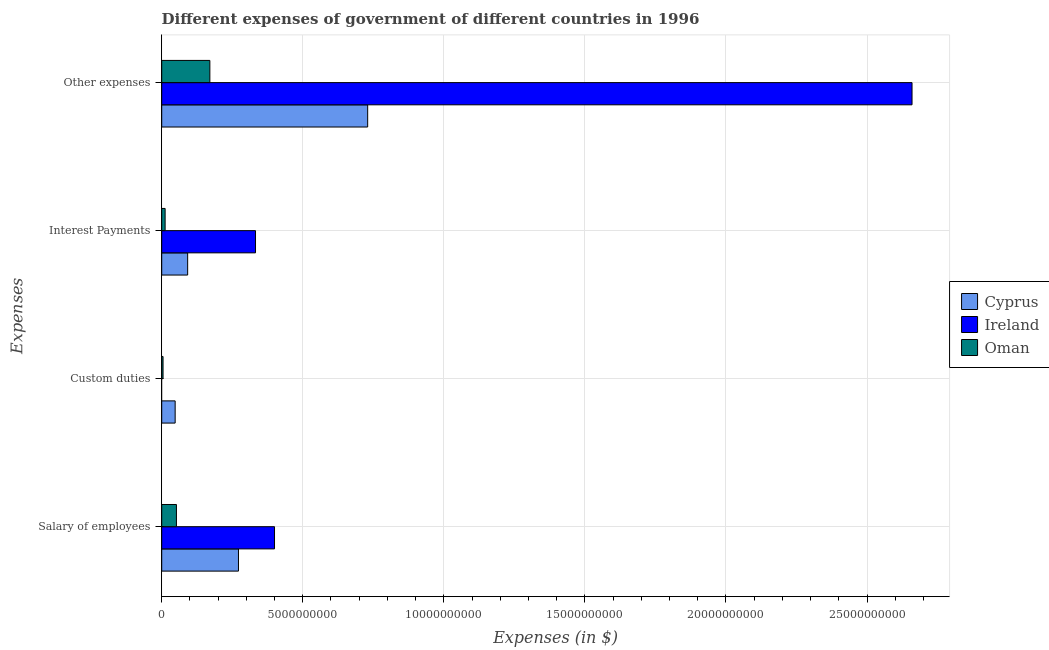Are the number of bars per tick equal to the number of legend labels?
Make the answer very short. No. Are the number of bars on each tick of the Y-axis equal?
Make the answer very short. No. How many bars are there on the 3rd tick from the top?
Your response must be concise. 2. What is the label of the 4th group of bars from the top?
Your response must be concise. Salary of employees. What is the amount spent on other expenses in Ireland?
Ensure brevity in your answer.  2.66e+1. Across all countries, what is the maximum amount spent on other expenses?
Ensure brevity in your answer.  2.66e+1. Across all countries, what is the minimum amount spent on interest payments?
Offer a terse response. 1.21e+08. In which country was the amount spent on other expenses maximum?
Keep it short and to the point. Ireland. What is the total amount spent on salary of employees in the graph?
Provide a succinct answer. 7.24e+09. What is the difference between the amount spent on other expenses in Cyprus and that in Ireland?
Your answer should be compact. -1.93e+1. What is the difference between the amount spent on interest payments in Ireland and the amount spent on salary of employees in Oman?
Provide a succinct answer. 2.80e+09. What is the average amount spent on interest payments per country?
Your answer should be very brief. 1.46e+09. What is the difference between the amount spent on salary of employees and amount spent on other expenses in Ireland?
Ensure brevity in your answer.  -2.26e+1. In how many countries, is the amount spent on salary of employees greater than 14000000000 $?
Provide a succinct answer. 0. What is the ratio of the amount spent on salary of employees in Cyprus to that in Oman?
Provide a short and direct response. 5.21. Is the difference between the amount spent on salary of employees in Oman and Ireland greater than the difference between the amount spent on interest payments in Oman and Ireland?
Make the answer very short. No. What is the difference between the highest and the second highest amount spent on salary of employees?
Make the answer very short. 1.28e+09. What is the difference between the highest and the lowest amount spent on custom duties?
Ensure brevity in your answer.  4.77e+08. Is the sum of the amount spent on other expenses in Oman and Ireland greater than the maximum amount spent on interest payments across all countries?
Give a very brief answer. Yes. Are all the bars in the graph horizontal?
Give a very brief answer. Yes. Does the graph contain any zero values?
Keep it short and to the point. Yes. Does the graph contain grids?
Offer a terse response. Yes. Where does the legend appear in the graph?
Provide a short and direct response. Center right. How many legend labels are there?
Offer a terse response. 3. How are the legend labels stacked?
Provide a short and direct response. Vertical. What is the title of the graph?
Provide a succinct answer. Different expenses of government of different countries in 1996. Does "Georgia" appear as one of the legend labels in the graph?
Your response must be concise. No. What is the label or title of the X-axis?
Make the answer very short. Expenses (in $). What is the label or title of the Y-axis?
Provide a succinct answer. Expenses. What is the Expenses (in $) in Cyprus in Salary of employees?
Your answer should be very brief. 2.72e+09. What is the Expenses (in $) in Ireland in Salary of employees?
Make the answer very short. 4.00e+09. What is the Expenses (in $) in Oman in Salary of employees?
Make the answer very short. 5.22e+08. What is the Expenses (in $) of Cyprus in Custom duties?
Ensure brevity in your answer.  4.77e+08. What is the Expenses (in $) of Ireland in Custom duties?
Your answer should be compact. 0. What is the Expenses (in $) in Oman in Custom duties?
Offer a terse response. 4.76e+07. What is the Expenses (in $) of Cyprus in Interest Payments?
Give a very brief answer. 9.20e+08. What is the Expenses (in $) in Ireland in Interest Payments?
Offer a very short reply. 3.32e+09. What is the Expenses (in $) in Oman in Interest Payments?
Give a very brief answer. 1.21e+08. What is the Expenses (in $) of Cyprus in Other expenses?
Your answer should be compact. 7.30e+09. What is the Expenses (in $) in Ireland in Other expenses?
Offer a terse response. 2.66e+1. What is the Expenses (in $) of Oman in Other expenses?
Ensure brevity in your answer.  1.71e+09. Across all Expenses, what is the maximum Expenses (in $) of Cyprus?
Offer a very short reply. 7.30e+09. Across all Expenses, what is the maximum Expenses (in $) in Ireland?
Give a very brief answer. 2.66e+1. Across all Expenses, what is the maximum Expenses (in $) in Oman?
Ensure brevity in your answer.  1.71e+09. Across all Expenses, what is the minimum Expenses (in $) in Cyprus?
Your answer should be compact. 4.77e+08. Across all Expenses, what is the minimum Expenses (in $) of Ireland?
Provide a short and direct response. 0. Across all Expenses, what is the minimum Expenses (in $) in Oman?
Ensure brevity in your answer.  4.76e+07. What is the total Expenses (in $) of Cyprus in the graph?
Make the answer very short. 1.14e+1. What is the total Expenses (in $) in Ireland in the graph?
Your answer should be compact. 3.39e+1. What is the total Expenses (in $) in Oman in the graph?
Provide a short and direct response. 2.40e+09. What is the difference between the Expenses (in $) in Cyprus in Salary of employees and that in Custom duties?
Ensure brevity in your answer.  2.24e+09. What is the difference between the Expenses (in $) in Oman in Salary of employees and that in Custom duties?
Give a very brief answer. 4.74e+08. What is the difference between the Expenses (in $) in Cyprus in Salary of employees and that in Interest Payments?
Provide a short and direct response. 1.80e+09. What is the difference between the Expenses (in $) of Ireland in Salary of employees and that in Interest Payments?
Offer a very short reply. 6.74e+08. What is the difference between the Expenses (in $) of Oman in Salary of employees and that in Interest Payments?
Provide a short and direct response. 4.01e+08. What is the difference between the Expenses (in $) of Cyprus in Salary of employees and that in Other expenses?
Your response must be concise. -4.58e+09. What is the difference between the Expenses (in $) of Ireland in Salary of employees and that in Other expenses?
Your answer should be very brief. -2.26e+1. What is the difference between the Expenses (in $) of Oman in Salary of employees and that in Other expenses?
Provide a short and direct response. -1.18e+09. What is the difference between the Expenses (in $) in Cyprus in Custom duties and that in Interest Payments?
Keep it short and to the point. -4.43e+08. What is the difference between the Expenses (in $) of Oman in Custom duties and that in Interest Payments?
Offer a terse response. -7.36e+07. What is the difference between the Expenses (in $) in Cyprus in Custom duties and that in Other expenses?
Your answer should be very brief. -6.82e+09. What is the difference between the Expenses (in $) in Oman in Custom duties and that in Other expenses?
Give a very brief answer. -1.66e+09. What is the difference between the Expenses (in $) of Cyprus in Interest Payments and that in Other expenses?
Keep it short and to the point. -6.38e+09. What is the difference between the Expenses (in $) of Ireland in Interest Payments and that in Other expenses?
Offer a very short reply. -2.33e+1. What is the difference between the Expenses (in $) of Oman in Interest Payments and that in Other expenses?
Provide a succinct answer. -1.59e+09. What is the difference between the Expenses (in $) of Cyprus in Salary of employees and the Expenses (in $) of Oman in Custom duties?
Provide a succinct answer. 2.67e+09. What is the difference between the Expenses (in $) of Ireland in Salary of employees and the Expenses (in $) of Oman in Custom duties?
Give a very brief answer. 3.95e+09. What is the difference between the Expenses (in $) of Cyprus in Salary of employees and the Expenses (in $) of Ireland in Interest Payments?
Offer a very short reply. -6.04e+08. What is the difference between the Expenses (in $) in Cyprus in Salary of employees and the Expenses (in $) in Oman in Interest Payments?
Provide a short and direct response. 2.60e+09. What is the difference between the Expenses (in $) in Ireland in Salary of employees and the Expenses (in $) in Oman in Interest Payments?
Provide a succinct answer. 3.88e+09. What is the difference between the Expenses (in $) of Cyprus in Salary of employees and the Expenses (in $) of Ireland in Other expenses?
Offer a very short reply. -2.39e+1. What is the difference between the Expenses (in $) in Cyprus in Salary of employees and the Expenses (in $) in Oman in Other expenses?
Provide a short and direct response. 1.01e+09. What is the difference between the Expenses (in $) in Ireland in Salary of employees and the Expenses (in $) in Oman in Other expenses?
Keep it short and to the point. 2.29e+09. What is the difference between the Expenses (in $) of Cyprus in Custom duties and the Expenses (in $) of Ireland in Interest Payments?
Provide a succinct answer. -2.85e+09. What is the difference between the Expenses (in $) in Cyprus in Custom duties and the Expenses (in $) in Oman in Interest Payments?
Ensure brevity in your answer.  3.56e+08. What is the difference between the Expenses (in $) in Cyprus in Custom duties and the Expenses (in $) in Ireland in Other expenses?
Make the answer very short. -2.61e+1. What is the difference between the Expenses (in $) in Cyprus in Custom duties and the Expenses (in $) in Oman in Other expenses?
Make the answer very short. -1.23e+09. What is the difference between the Expenses (in $) in Cyprus in Interest Payments and the Expenses (in $) in Ireland in Other expenses?
Provide a short and direct response. -2.57e+1. What is the difference between the Expenses (in $) in Cyprus in Interest Payments and the Expenses (in $) in Oman in Other expenses?
Your answer should be very brief. -7.87e+08. What is the difference between the Expenses (in $) of Ireland in Interest Payments and the Expenses (in $) of Oman in Other expenses?
Your response must be concise. 1.62e+09. What is the average Expenses (in $) of Cyprus per Expenses?
Your response must be concise. 2.85e+09. What is the average Expenses (in $) of Ireland per Expenses?
Provide a succinct answer. 8.48e+09. What is the average Expenses (in $) in Oman per Expenses?
Keep it short and to the point. 5.99e+08. What is the difference between the Expenses (in $) of Cyprus and Expenses (in $) of Ireland in Salary of employees?
Give a very brief answer. -1.28e+09. What is the difference between the Expenses (in $) in Cyprus and Expenses (in $) in Oman in Salary of employees?
Give a very brief answer. 2.20e+09. What is the difference between the Expenses (in $) in Ireland and Expenses (in $) in Oman in Salary of employees?
Ensure brevity in your answer.  3.48e+09. What is the difference between the Expenses (in $) in Cyprus and Expenses (in $) in Oman in Custom duties?
Keep it short and to the point. 4.29e+08. What is the difference between the Expenses (in $) in Cyprus and Expenses (in $) in Ireland in Interest Payments?
Provide a succinct answer. -2.40e+09. What is the difference between the Expenses (in $) of Cyprus and Expenses (in $) of Oman in Interest Payments?
Keep it short and to the point. 7.99e+08. What is the difference between the Expenses (in $) of Ireland and Expenses (in $) of Oman in Interest Payments?
Offer a terse response. 3.20e+09. What is the difference between the Expenses (in $) of Cyprus and Expenses (in $) of Ireland in Other expenses?
Offer a very short reply. -1.93e+1. What is the difference between the Expenses (in $) of Cyprus and Expenses (in $) of Oman in Other expenses?
Make the answer very short. 5.59e+09. What is the difference between the Expenses (in $) in Ireland and Expenses (in $) in Oman in Other expenses?
Make the answer very short. 2.49e+1. What is the ratio of the Expenses (in $) of Cyprus in Salary of employees to that in Custom duties?
Keep it short and to the point. 5.71. What is the ratio of the Expenses (in $) of Oman in Salary of employees to that in Custom duties?
Your answer should be compact. 10.96. What is the ratio of the Expenses (in $) of Cyprus in Salary of employees to that in Interest Payments?
Your response must be concise. 2.96. What is the ratio of the Expenses (in $) of Ireland in Salary of employees to that in Interest Payments?
Keep it short and to the point. 1.2. What is the ratio of the Expenses (in $) in Oman in Salary of employees to that in Interest Payments?
Keep it short and to the point. 4.31. What is the ratio of the Expenses (in $) in Cyprus in Salary of employees to that in Other expenses?
Offer a terse response. 0.37. What is the ratio of the Expenses (in $) of Ireland in Salary of employees to that in Other expenses?
Your answer should be very brief. 0.15. What is the ratio of the Expenses (in $) of Oman in Salary of employees to that in Other expenses?
Ensure brevity in your answer.  0.31. What is the ratio of the Expenses (in $) of Cyprus in Custom duties to that in Interest Payments?
Your response must be concise. 0.52. What is the ratio of the Expenses (in $) in Oman in Custom duties to that in Interest Payments?
Your answer should be compact. 0.39. What is the ratio of the Expenses (in $) in Cyprus in Custom duties to that in Other expenses?
Provide a short and direct response. 0.07. What is the ratio of the Expenses (in $) of Oman in Custom duties to that in Other expenses?
Your answer should be compact. 0.03. What is the ratio of the Expenses (in $) in Cyprus in Interest Payments to that in Other expenses?
Your response must be concise. 0.13. What is the ratio of the Expenses (in $) in Ireland in Interest Payments to that in Other expenses?
Provide a short and direct response. 0.12. What is the ratio of the Expenses (in $) in Oman in Interest Payments to that in Other expenses?
Your answer should be compact. 0.07. What is the difference between the highest and the second highest Expenses (in $) of Cyprus?
Keep it short and to the point. 4.58e+09. What is the difference between the highest and the second highest Expenses (in $) of Ireland?
Your answer should be very brief. 2.26e+1. What is the difference between the highest and the second highest Expenses (in $) in Oman?
Keep it short and to the point. 1.18e+09. What is the difference between the highest and the lowest Expenses (in $) in Cyprus?
Your response must be concise. 6.82e+09. What is the difference between the highest and the lowest Expenses (in $) in Ireland?
Your answer should be very brief. 2.66e+1. What is the difference between the highest and the lowest Expenses (in $) in Oman?
Provide a succinct answer. 1.66e+09. 